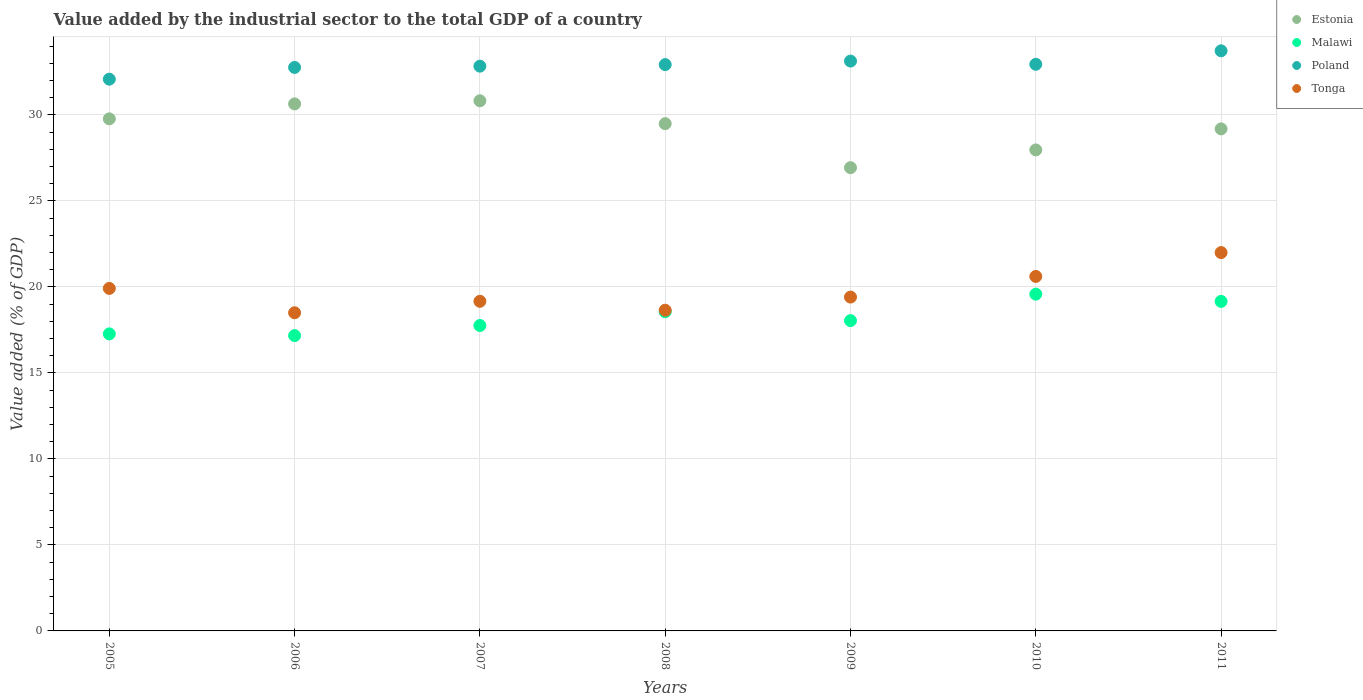How many different coloured dotlines are there?
Your answer should be very brief. 4. What is the value added by the industrial sector to the total GDP in Malawi in 2010?
Offer a terse response. 19.58. Across all years, what is the maximum value added by the industrial sector to the total GDP in Malawi?
Give a very brief answer. 19.58. Across all years, what is the minimum value added by the industrial sector to the total GDP in Estonia?
Make the answer very short. 26.94. In which year was the value added by the industrial sector to the total GDP in Poland minimum?
Provide a succinct answer. 2005. What is the total value added by the industrial sector to the total GDP in Malawi in the graph?
Keep it short and to the point. 127.55. What is the difference between the value added by the industrial sector to the total GDP in Tonga in 2005 and that in 2007?
Ensure brevity in your answer.  0.75. What is the difference between the value added by the industrial sector to the total GDP in Estonia in 2005 and the value added by the industrial sector to the total GDP in Tonga in 2007?
Keep it short and to the point. 10.61. What is the average value added by the industrial sector to the total GDP in Tonga per year?
Make the answer very short. 19.75. In the year 2008, what is the difference between the value added by the industrial sector to the total GDP in Malawi and value added by the industrial sector to the total GDP in Estonia?
Keep it short and to the point. -10.93. What is the ratio of the value added by the industrial sector to the total GDP in Estonia in 2005 to that in 2011?
Keep it short and to the point. 1.02. Is the value added by the industrial sector to the total GDP in Malawi in 2008 less than that in 2009?
Provide a short and direct response. No. Is the difference between the value added by the industrial sector to the total GDP in Malawi in 2005 and 2011 greater than the difference between the value added by the industrial sector to the total GDP in Estonia in 2005 and 2011?
Keep it short and to the point. No. What is the difference between the highest and the second highest value added by the industrial sector to the total GDP in Malawi?
Keep it short and to the point. 0.42. What is the difference between the highest and the lowest value added by the industrial sector to the total GDP in Estonia?
Provide a short and direct response. 3.89. In how many years, is the value added by the industrial sector to the total GDP in Estonia greater than the average value added by the industrial sector to the total GDP in Estonia taken over all years?
Your answer should be very brief. 4. Is the sum of the value added by the industrial sector to the total GDP in Poland in 2005 and 2011 greater than the maximum value added by the industrial sector to the total GDP in Estonia across all years?
Offer a terse response. Yes. How many dotlines are there?
Provide a short and direct response. 4. How many years are there in the graph?
Ensure brevity in your answer.  7. Are the values on the major ticks of Y-axis written in scientific E-notation?
Ensure brevity in your answer.  No. How many legend labels are there?
Give a very brief answer. 4. What is the title of the graph?
Ensure brevity in your answer.  Value added by the industrial sector to the total GDP of a country. What is the label or title of the Y-axis?
Provide a succinct answer. Value added (% of GDP). What is the Value added (% of GDP) of Estonia in 2005?
Offer a very short reply. 29.78. What is the Value added (% of GDP) of Malawi in 2005?
Give a very brief answer. 17.27. What is the Value added (% of GDP) in Poland in 2005?
Give a very brief answer. 32.08. What is the Value added (% of GDP) of Tonga in 2005?
Provide a succinct answer. 19.92. What is the Value added (% of GDP) of Estonia in 2006?
Provide a short and direct response. 30.64. What is the Value added (% of GDP) in Malawi in 2006?
Offer a very short reply. 17.17. What is the Value added (% of GDP) of Poland in 2006?
Your response must be concise. 32.76. What is the Value added (% of GDP) in Tonga in 2006?
Keep it short and to the point. 18.5. What is the Value added (% of GDP) of Estonia in 2007?
Your answer should be compact. 30.83. What is the Value added (% of GDP) in Malawi in 2007?
Your answer should be very brief. 17.76. What is the Value added (% of GDP) in Poland in 2007?
Your answer should be very brief. 32.84. What is the Value added (% of GDP) in Tonga in 2007?
Ensure brevity in your answer.  19.17. What is the Value added (% of GDP) in Estonia in 2008?
Give a very brief answer. 29.5. What is the Value added (% of GDP) in Malawi in 2008?
Keep it short and to the point. 18.56. What is the Value added (% of GDP) in Poland in 2008?
Offer a very short reply. 32.93. What is the Value added (% of GDP) in Tonga in 2008?
Offer a very short reply. 18.65. What is the Value added (% of GDP) of Estonia in 2009?
Provide a succinct answer. 26.94. What is the Value added (% of GDP) of Malawi in 2009?
Offer a terse response. 18.04. What is the Value added (% of GDP) in Poland in 2009?
Your answer should be very brief. 33.13. What is the Value added (% of GDP) in Tonga in 2009?
Provide a short and direct response. 19.41. What is the Value added (% of GDP) of Estonia in 2010?
Make the answer very short. 27.97. What is the Value added (% of GDP) in Malawi in 2010?
Ensure brevity in your answer.  19.58. What is the Value added (% of GDP) of Poland in 2010?
Your answer should be compact. 32.95. What is the Value added (% of GDP) in Tonga in 2010?
Your response must be concise. 20.61. What is the Value added (% of GDP) in Estonia in 2011?
Ensure brevity in your answer.  29.19. What is the Value added (% of GDP) in Malawi in 2011?
Your response must be concise. 19.16. What is the Value added (% of GDP) of Poland in 2011?
Provide a short and direct response. 33.73. What is the Value added (% of GDP) of Tonga in 2011?
Your answer should be compact. 22. Across all years, what is the maximum Value added (% of GDP) in Estonia?
Offer a terse response. 30.83. Across all years, what is the maximum Value added (% of GDP) of Malawi?
Your answer should be very brief. 19.58. Across all years, what is the maximum Value added (% of GDP) in Poland?
Keep it short and to the point. 33.73. Across all years, what is the maximum Value added (% of GDP) in Tonga?
Make the answer very short. 22. Across all years, what is the minimum Value added (% of GDP) of Estonia?
Offer a very short reply. 26.94. Across all years, what is the minimum Value added (% of GDP) in Malawi?
Ensure brevity in your answer.  17.17. Across all years, what is the minimum Value added (% of GDP) in Poland?
Your answer should be compact. 32.08. Across all years, what is the minimum Value added (% of GDP) in Tonga?
Offer a very short reply. 18.5. What is the total Value added (% of GDP) of Estonia in the graph?
Give a very brief answer. 204.84. What is the total Value added (% of GDP) in Malawi in the graph?
Keep it short and to the point. 127.55. What is the total Value added (% of GDP) in Poland in the graph?
Offer a terse response. 230.43. What is the total Value added (% of GDP) in Tonga in the graph?
Offer a very short reply. 138.25. What is the difference between the Value added (% of GDP) in Estonia in 2005 and that in 2006?
Make the answer very short. -0.87. What is the difference between the Value added (% of GDP) in Malawi in 2005 and that in 2006?
Your response must be concise. 0.1. What is the difference between the Value added (% of GDP) of Poland in 2005 and that in 2006?
Give a very brief answer. -0.68. What is the difference between the Value added (% of GDP) in Tonga in 2005 and that in 2006?
Offer a terse response. 1.42. What is the difference between the Value added (% of GDP) of Estonia in 2005 and that in 2007?
Your response must be concise. -1.05. What is the difference between the Value added (% of GDP) of Malawi in 2005 and that in 2007?
Provide a short and direct response. -0.49. What is the difference between the Value added (% of GDP) in Poland in 2005 and that in 2007?
Your answer should be very brief. -0.76. What is the difference between the Value added (% of GDP) of Tonga in 2005 and that in 2007?
Offer a terse response. 0.75. What is the difference between the Value added (% of GDP) in Estonia in 2005 and that in 2008?
Provide a succinct answer. 0.28. What is the difference between the Value added (% of GDP) in Malawi in 2005 and that in 2008?
Provide a short and direct response. -1.29. What is the difference between the Value added (% of GDP) of Poland in 2005 and that in 2008?
Your answer should be very brief. -0.85. What is the difference between the Value added (% of GDP) in Tonga in 2005 and that in 2008?
Offer a very short reply. 1.27. What is the difference between the Value added (% of GDP) of Estonia in 2005 and that in 2009?
Your response must be concise. 2.84. What is the difference between the Value added (% of GDP) in Malawi in 2005 and that in 2009?
Your answer should be very brief. -0.77. What is the difference between the Value added (% of GDP) in Poland in 2005 and that in 2009?
Provide a short and direct response. -1.05. What is the difference between the Value added (% of GDP) in Tonga in 2005 and that in 2009?
Your answer should be very brief. 0.5. What is the difference between the Value added (% of GDP) of Estonia in 2005 and that in 2010?
Make the answer very short. 1.81. What is the difference between the Value added (% of GDP) in Malawi in 2005 and that in 2010?
Provide a succinct answer. -2.31. What is the difference between the Value added (% of GDP) of Poland in 2005 and that in 2010?
Ensure brevity in your answer.  -0.87. What is the difference between the Value added (% of GDP) of Tonga in 2005 and that in 2010?
Ensure brevity in your answer.  -0.7. What is the difference between the Value added (% of GDP) in Estonia in 2005 and that in 2011?
Offer a very short reply. 0.58. What is the difference between the Value added (% of GDP) in Malawi in 2005 and that in 2011?
Provide a succinct answer. -1.89. What is the difference between the Value added (% of GDP) of Poland in 2005 and that in 2011?
Provide a succinct answer. -1.65. What is the difference between the Value added (% of GDP) of Tonga in 2005 and that in 2011?
Offer a terse response. -2.08. What is the difference between the Value added (% of GDP) in Estonia in 2006 and that in 2007?
Ensure brevity in your answer.  -0.18. What is the difference between the Value added (% of GDP) of Malawi in 2006 and that in 2007?
Your response must be concise. -0.59. What is the difference between the Value added (% of GDP) in Poland in 2006 and that in 2007?
Your answer should be very brief. -0.07. What is the difference between the Value added (% of GDP) in Tonga in 2006 and that in 2007?
Keep it short and to the point. -0.67. What is the difference between the Value added (% of GDP) of Estonia in 2006 and that in 2008?
Ensure brevity in your answer.  1.15. What is the difference between the Value added (% of GDP) of Malawi in 2006 and that in 2008?
Ensure brevity in your answer.  -1.39. What is the difference between the Value added (% of GDP) in Poland in 2006 and that in 2008?
Offer a terse response. -0.16. What is the difference between the Value added (% of GDP) of Tonga in 2006 and that in 2008?
Keep it short and to the point. -0.15. What is the difference between the Value added (% of GDP) in Estonia in 2006 and that in 2009?
Provide a short and direct response. 3.71. What is the difference between the Value added (% of GDP) in Malawi in 2006 and that in 2009?
Keep it short and to the point. -0.87. What is the difference between the Value added (% of GDP) of Poland in 2006 and that in 2009?
Make the answer very short. -0.37. What is the difference between the Value added (% of GDP) in Tonga in 2006 and that in 2009?
Your answer should be very brief. -0.91. What is the difference between the Value added (% of GDP) in Estonia in 2006 and that in 2010?
Provide a succinct answer. 2.68. What is the difference between the Value added (% of GDP) of Malawi in 2006 and that in 2010?
Give a very brief answer. -2.41. What is the difference between the Value added (% of GDP) of Poland in 2006 and that in 2010?
Your answer should be compact. -0.18. What is the difference between the Value added (% of GDP) of Tonga in 2006 and that in 2010?
Give a very brief answer. -2.11. What is the difference between the Value added (% of GDP) of Estonia in 2006 and that in 2011?
Ensure brevity in your answer.  1.45. What is the difference between the Value added (% of GDP) in Malawi in 2006 and that in 2011?
Keep it short and to the point. -1.99. What is the difference between the Value added (% of GDP) of Poland in 2006 and that in 2011?
Make the answer very short. -0.97. What is the difference between the Value added (% of GDP) in Tonga in 2006 and that in 2011?
Ensure brevity in your answer.  -3.5. What is the difference between the Value added (% of GDP) of Estonia in 2007 and that in 2008?
Give a very brief answer. 1.33. What is the difference between the Value added (% of GDP) in Malawi in 2007 and that in 2008?
Your response must be concise. -0.8. What is the difference between the Value added (% of GDP) of Poland in 2007 and that in 2008?
Ensure brevity in your answer.  -0.09. What is the difference between the Value added (% of GDP) of Tonga in 2007 and that in 2008?
Give a very brief answer. 0.52. What is the difference between the Value added (% of GDP) of Estonia in 2007 and that in 2009?
Ensure brevity in your answer.  3.89. What is the difference between the Value added (% of GDP) in Malawi in 2007 and that in 2009?
Offer a very short reply. -0.28. What is the difference between the Value added (% of GDP) in Poland in 2007 and that in 2009?
Give a very brief answer. -0.3. What is the difference between the Value added (% of GDP) of Tonga in 2007 and that in 2009?
Keep it short and to the point. -0.25. What is the difference between the Value added (% of GDP) in Estonia in 2007 and that in 2010?
Keep it short and to the point. 2.86. What is the difference between the Value added (% of GDP) in Malawi in 2007 and that in 2010?
Keep it short and to the point. -1.82. What is the difference between the Value added (% of GDP) of Poland in 2007 and that in 2010?
Provide a succinct answer. -0.11. What is the difference between the Value added (% of GDP) in Tonga in 2007 and that in 2010?
Make the answer very short. -1.45. What is the difference between the Value added (% of GDP) in Estonia in 2007 and that in 2011?
Provide a succinct answer. 1.63. What is the difference between the Value added (% of GDP) of Malawi in 2007 and that in 2011?
Offer a terse response. -1.4. What is the difference between the Value added (% of GDP) of Poland in 2007 and that in 2011?
Your response must be concise. -0.89. What is the difference between the Value added (% of GDP) in Tonga in 2007 and that in 2011?
Your answer should be compact. -2.83. What is the difference between the Value added (% of GDP) in Estonia in 2008 and that in 2009?
Provide a succinct answer. 2.56. What is the difference between the Value added (% of GDP) in Malawi in 2008 and that in 2009?
Make the answer very short. 0.52. What is the difference between the Value added (% of GDP) in Poland in 2008 and that in 2009?
Offer a terse response. -0.21. What is the difference between the Value added (% of GDP) of Tonga in 2008 and that in 2009?
Keep it short and to the point. -0.76. What is the difference between the Value added (% of GDP) in Estonia in 2008 and that in 2010?
Provide a succinct answer. 1.53. What is the difference between the Value added (% of GDP) of Malawi in 2008 and that in 2010?
Ensure brevity in your answer.  -1.02. What is the difference between the Value added (% of GDP) of Poland in 2008 and that in 2010?
Your response must be concise. -0.02. What is the difference between the Value added (% of GDP) of Tonga in 2008 and that in 2010?
Offer a very short reply. -1.96. What is the difference between the Value added (% of GDP) in Estonia in 2008 and that in 2011?
Provide a short and direct response. 0.3. What is the difference between the Value added (% of GDP) of Malawi in 2008 and that in 2011?
Make the answer very short. -0.6. What is the difference between the Value added (% of GDP) in Poland in 2008 and that in 2011?
Make the answer very short. -0.8. What is the difference between the Value added (% of GDP) of Tonga in 2008 and that in 2011?
Keep it short and to the point. -3.35. What is the difference between the Value added (% of GDP) of Estonia in 2009 and that in 2010?
Give a very brief answer. -1.03. What is the difference between the Value added (% of GDP) in Malawi in 2009 and that in 2010?
Provide a succinct answer. -1.54. What is the difference between the Value added (% of GDP) of Poland in 2009 and that in 2010?
Provide a succinct answer. 0.19. What is the difference between the Value added (% of GDP) in Tonga in 2009 and that in 2010?
Offer a terse response. -1.2. What is the difference between the Value added (% of GDP) of Estonia in 2009 and that in 2011?
Offer a very short reply. -2.26. What is the difference between the Value added (% of GDP) of Malawi in 2009 and that in 2011?
Give a very brief answer. -1.12. What is the difference between the Value added (% of GDP) of Poland in 2009 and that in 2011?
Provide a succinct answer. -0.6. What is the difference between the Value added (% of GDP) in Tonga in 2009 and that in 2011?
Offer a very short reply. -2.59. What is the difference between the Value added (% of GDP) in Estonia in 2010 and that in 2011?
Provide a succinct answer. -1.22. What is the difference between the Value added (% of GDP) of Malawi in 2010 and that in 2011?
Your answer should be compact. 0.42. What is the difference between the Value added (% of GDP) of Poland in 2010 and that in 2011?
Provide a short and direct response. -0.78. What is the difference between the Value added (% of GDP) of Tonga in 2010 and that in 2011?
Your response must be concise. -1.39. What is the difference between the Value added (% of GDP) in Estonia in 2005 and the Value added (% of GDP) in Malawi in 2006?
Your response must be concise. 12.6. What is the difference between the Value added (% of GDP) of Estonia in 2005 and the Value added (% of GDP) of Poland in 2006?
Ensure brevity in your answer.  -2.99. What is the difference between the Value added (% of GDP) of Estonia in 2005 and the Value added (% of GDP) of Tonga in 2006?
Provide a succinct answer. 11.28. What is the difference between the Value added (% of GDP) in Malawi in 2005 and the Value added (% of GDP) in Poland in 2006?
Your response must be concise. -15.49. What is the difference between the Value added (% of GDP) of Malawi in 2005 and the Value added (% of GDP) of Tonga in 2006?
Make the answer very short. -1.23. What is the difference between the Value added (% of GDP) of Poland in 2005 and the Value added (% of GDP) of Tonga in 2006?
Ensure brevity in your answer.  13.58. What is the difference between the Value added (% of GDP) in Estonia in 2005 and the Value added (% of GDP) in Malawi in 2007?
Offer a very short reply. 12.02. What is the difference between the Value added (% of GDP) in Estonia in 2005 and the Value added (% of GDP) in Poland in 2007?
Keep it short and to the point. -3.06. What is the difference between the Value added (% of GDP) in Estonia in 2005 and the Value added (% of GDP) in Tonga in 2007?
Provide a short and direct response. 10.61. What is the difference between the Value added (% of GDP) in Malawi in 2005 and the Value added (% of GDP) in Poland in 2007?
Give a very brief answer. -15.57. What is the difference between the Value added (% of GDP) in Malawi in 2005 and the Value added (% of GDP) in Tonga in 2007?
Your answer should be compact. -1.89. What is the difference between the Value added (% of GDP) in Poland in 2005 and the Value added (% of GDP) in Tonga in 2007?
Your response must be concise. 12.92. What is the difference between the Value added (% of GDP) of Estonia in 2005 and the Value added (% of GDP) of Malawi in 2008?
Your response must be concise. 11.21. What is the difference between the Value added (% of GDP) in Estonia in 2005 and the Value added (% of GDP) in Poland in 2008?
Offer a very short reply. -3.15. What is the difference between the Value added (% of GDP) in Estonia in 2005 and the Value added (% of GDP) in Tonga in 2008?
Keep it short and to the point. 11.13. What is the difference between the Value added (% of GDP) of Malawi in 2005 and the Value added (% of GDP) of Poland in 2008?
Make the answer very short. -15.66. What is the difference between the Value added (% of GDP) of Malawi in 2005 and the Value added (% of GDP) of Tonga in 2008?
Provide a succinct answer. -1.38. What is the difference between the Value added (% of GDP) of Poland in 2005 and the Value added (% of GDP) of Tonga in 2008?
Give a very brief answer. 13.43. What is the difference between the Value added (% of GDP) in Estonia in 2005 and the Value added (% of GDP) in Malawi in 2009?
Give a very brief answer. 11.73. What is the difference between the Value added (% of GDP) of Estonia in 2005 and the Value added (% of GDP) of Poland in 2009?
Provide a short and direct response. -3.36. What is the difference between the Value added (% of GDP) of Estonia in 2005 and the Value added (% of GDP) of Tonga in 2009?
Offer a very short reply. 10.36. What is the difference between the Value added (% of GDP) of Malawi in 2005 and the Value added (% of GDP) of Poland in 2009?
Make the answer very short. -15.86. What is the difference between the Value added (% of GDP) of Malawi in 2005 and the Value added (% of GDP) of Tonga in 2009?
Your response must be concise. -2.14. What is the difference between the Value added (% of GDP) in Poland in 2005 and the Value added (% of GDP) in Tonga in 2009?
Make the answer very short. 12.67. What is the difference between the Value added (% of GDP) in Estonia in 2005 and the Value added (% of GDP) in Malawi in 2010?
Give a very brief answer. 10.19. What is the difference between the Value added (% of GDP) of Estonia in 2005 and the Value added (% of GDP) of Poland in 2010?
Your answer should be very brief. -3.17. What is the difference between the Value added (% of GDP) in Estonia in 2005 and the Value added (% of GDP) in Tonga in 2010?
Offer a terse response. 9.16. What is the difference between the Value added (% of GDP) of Malawi in 2005 and the Value added (% of GDP) of Poland in 2010?
Offer a terse response. -15.68. What is the difference between the Value added (% of GDP) of Malawi in 2005 and the Value added (% of GDP) of Tonga in 2010?
Offer a very short reply. -3.34. What is the difference between the Value added (% of GDP) in Poland in 2005 and the Value added (% of GDP) in Tonga in 2010?
Your response must be concise. 11.47. What is the difference between the Value added (% of GDP) of Estonia in 2005 and the Value added (% of GDP) of Malawi in 2011?
Your response must be concise. 10.61. What is the difference between the Value added (% of GDP) of Estonia in 2005 and the Value added (% of GDP) of Poland in 2011?
Your answer should be very brief. -3.96. What is the difference between the Value added (% of GDP) in Estonia in 2005 and the Value added (% of GDP) in Tonga in 2011?
Your answer should be compact. 7.78. What is the difference between the Value added (% of GDP) of Malawi in 2005 and the Value added (% of GDP) of Poland in 2011?
Offer a very short reply. -16.46. What is the difference between the Value added (% of GDP) in Malawi in 2005 and the Value added (% of GDP) in Tonga in 2011?
Make the answer very short. -4.73. What is the difference between the Value added (% of GDP) in Poland in 2005 and the Value added (% of GDP) in Tonga in 2011?
Provide a succinct answer. 10.08. What is the difference between the Value added (% of GDP) of Estonia in 2006 and the Value added (% of GDP) of Malawi in 2007?
Provide a short and direct response. 12.89. What is the difference between the Value added (% of GDP) in Estonia in 2006 and the Value added (% of GDP) in Poland in 2007?
Your response must be concise. -2.19. What is the difference between the Value added (% of GDP) in Estonia in 2006 and the Value added (% of GDP) in Tonga in 2007?
Offer a terse response. 11.48. What is the difference between the Value added (% of GDP) of Malawi in 2006 and the Value added (% of GDP) of Poland in 2007?
Ensure brevity in your answer.  -15.67. What is the difference between the Value added (% of GDP) of Malawi in 2006 and the Value added (% of GDP) of Tonga in 2007?
Your response must be concise. -1.99. What is the difference between the Value added (% of GDP) of Poland in 2006 and the Value added (% of GDP) of Tonga in 2007?
Your answer should be compact. 13.6. What is the difference between the Value added (% of GDP) in Estonia in 2006 and the Value added (% of GDP) in Malawi in 2008?
Keep it short and to the point. 12.08. What is the difference between the Value added (% of GDP) of Estonia in 2006 and the Value added (% of GDP) of Poland in 2008?
Your answer should be very brief. -2.28. What is the difference between the Value added (% of GDP) of Estonia in 2006 and the Value added (% of GDP) of Tonga in 2008?
Provide a short and direct response. 12. What is the difference between the Value added (% of GDP) in Malawi in 2006 and the Value added (% of GDP) in Poland in 2008?
Your response must be concise. -15.76. What is the difference between the Value added (% of GDP) in Malawi in 2006 and the Value added (% of GDP) in Tonga in 2008?
Ensure brevity in your answer.  -1.47. What is the difference between the Value added (% of GDP) of Poland in 2006 and the Value added (% of GDP) of Tonga in 2008?
Provide a short and direct response. 14.12. What is the difference between the Value added (% of GDP) in Estonia in 2006 and the Value added (% of GDP) in Malawi in 2009?
Ensure brevity in your answer.  12.6. What is the difference between the Value added (% of GDP) in Estonia in 2006 and the Value added (% of GDP) in Poland in 2009?
Provide a short and direct response. -2.49. What is the difference between the Value added (% of GDP) in Estonia in 2006 and the Value added (% of GDP) in Tonga in 2009?
Make the answer very short. 11.23. What is the difference between the Value added (% of GDP) of Malawi in 2006 and the Value added (% of GDP) of Poland in 2009?
Offer a very short reply. -15.96. What is the difference between the Value added (% of GDP) in Malawi in 2006 and the Value added (% of GDP) in Tonga in 2009?
Your answer should be compact. -2.24. What is the difference between the Value added (% of GDP) in Poland in 2006 and the Value added (% of GDP) in Tonga in 2009?
Offer a very short reply. 13.35. What is the difference between the Value added (% of GDP) of Estonia in 2006 and the Value added (% of GDP) of Malawi in 2010?
Keep it short and to the point. 11.06. What is the difference between the Value added (% of GDP) in Estonia in 2006 and the Value added (% of GDP) in Poland in 2010?
Provide a succinct answer. -2.3. What is the difference between the Value added (% of GDP) of Estonia in 2006 and the Value added (% of GDP) of Tonga in 2010?
Ensure brevity in your answer.  10.03. What is the difference between the Value added (% of GDP) in Malawi in 2006 and the Value added (% of GDP) in Poland in 2010?
Ensure brevity in your answer.  -15.77. What is the difference between the Value added (% of GDP) of Malawi in 2006 and the Value added (% of GDP) of Tonga in 2010?
Provide a short and direct response. -3.44. What is the difference between the Value added (% of GDP) of Poland in 2006 and the Value added (% of GDP) of Tonga in 2010?
Your answer should be compact. 12.15. What is the difference between the Value added (% of GDP) of Estonia in 2006 and the Value added (% of GDP) of Malawi in 2011?
Offer a terse response. 11.48. What is the difference between the Value added (% of GDP) of Estonia in 2006 and the Value added (% of GDP) of Poland in 2011?
Offer a terse response. -3.09. What is the difference between the Value added (% of GDP) in Estonia in 2006 and the Value added (% of GDP) in Tonga in 2011?
Offer a terse response. 8.65. What is the difference between the Value added (% of GDP) in Malawi in 2006 and the Value added (% of GDP) in Poland in 2011?
Your answer should be compact. -16.56. What is the difference between the Value added (% of GDP) in Malawi in 2006 and the Value added (% of GDP) in Tonga in 2011?
Your response must be concise. -4.83. What is the difference between the Value added (% of GDP) in Poland in 2006 and the Value added (% of GDP) in Tonga in 2011?
Your response must be concise. 10.77. What is the difference between the Value added (% of GDP) of Estonia in 2007 and the Value added (% of GDP) of Malawi in 2008?
Provide a succinct answer. 12.27. What is the difference between the Value added (% of GDP) in Estonia in 2007 and the Value added (% of GDP) in Poland in 2008?
Keep it short and to the point. -2.1. What is the difference between the Value added (% of GDP) of Estonia in 2007 and the Value added (% of GDP) of Tonga in 2008?
Your answer should be compact. 12.18. What is the difference between the Value added (% of GDP) of Malawi in 2007 and the Value added (% of GDP) of Poland in 2008?
Give a very brief answer. -15.17. What is the difference between the Value added (% of GDP) in Malawi in 2007 and the Value added (% of GDP) in Tonga in 2008?
Ensure brevity in your answer.  -0.89. What is the difference between the Value added (% of GDP) of Poland in 2007 and the Value added (% of GDP) of Tonga in 2008?
Your response must be concise. 14.19. What is the difference between the Value added (% of GDP) of Estonia in 2007 and the Value added (% of GDP) of Malawi in 2009?
Keep it short and to the point. 12.78. What is the difference between the Value added (% of GDP) in Estonia in 2007 and the Value added (% of GDP) in Poland in 2009?
Make the answer very short. -2.31. What is the difference between the Value added (% of GDP) in Estonia in 2007 and the Value added (% of GDP) in Tonga in 2009?
Your answer should be very brief. 11.41. What is the difference between the Value added (% of GDP) of Malawi in 2007 and the Value added (% of GDP) of Poland in 2009?
Keep it short and to the point. -15.38. What is the difference between the Value added (% of GDP) of Malawi in 2007 and the Value added (% of GDP) of Tonga in 2009?
Provide a short and direct response. -1.65. What is the difference between the Value added (% of GDP) in Poland in 2007 and the Value added (% of GDP) in Tonga in 2009?
Your response must be concise. 13.43. What is the difference between the Value added (% of GDP) in Estonia in 2007 and the Value added (% of GDP) in Malawi in 2010?
Give a very brief answer. 11.24. What is the difference between the Value added (% of GDP) of Estonia in 2007 and the Value added (% of GDP) of Poland in 2010?
Provide a short and direct response. -2.12. What is the difference between the Value added (% of GDP) of Estonia in 2007 and the Value added (% of GDP) of Tonga in 2010?
Keep it short and to the point. 10.21. What is the difference between the Value added (% of GDP) of Malawi in 2007 and the Value added (% of GDP) of Poland in 2010?
Your answer should be compact. -15.19. What is the difference between the Value added (% of GDP) of Malawi in 2007 and the Value added (% of GDP) of Tonga in 2010?
Keep it short and to the point. -2.85. What is the difference between the Value added (% of GDP) in Poland in 2007 and the Value added (% of GDP) in Tonga in 2010?
Make the answer very short. 12.23. What is the difference between the Value added (% of GDP) of Estonia in 2007 and the Value added (% of GDP) of Malawi in 2011?
Offer a terse response. 11.67. What is the difference between the Value added (% of GDP) of Estonia in 2007 and the Value added (% of GDP) of Poland in 2011?
Offer a terse response. -2.9. What is the difference between the Value added (% of GDP) in Estonia in 2007 and the Value added (% of GDP) in Tonga in 2011?
Offer a terse response. 8.83. What is the difference between the Value added (% of GDP) of Malawi in 2007 and the Value added (% of GDP) of Poland in 2011?
Offer a very short reply. -15.97. What is the difference between the Value added (% of GDP) of Malawi in 2007 and the Value added (% of GDP) of Tonga in 2011?
Ensure brevity in your answer.  -4.24. What is the difference between the Value added (% of GDP) in Poland in 2007 and the Value added (% of GDP) in Tonga in 2011?
Provide a succinct answer. 10.84. What is the difference between the Value added (% of GDP) of Estonia in 2008 and the Value added (% of GDP) of Malawi in 2009?
Your answer should be very brief. 11.45. What is the difference between the Value added (% of GDP) of Estonia in 2008 and the Value added (% of GDP) of Poland in 2009?
Offer a terse response. -3.64. What is the difference between the Value added (% of GDP) of Estonia in 2008 and the Value added (% of GDP) of Tonga in 2009?
Ensure brevity in your answer.  10.08. What is the difference between the Value added (% of GDP) of Malawi in 2008 and the Value added (% of GDP) of Poland in 2009?
Provide a succinct answer. -14.57. What is the difference between the Value added (% of GDP) of Malawi in 2008 and the Value added (% of GDP) of Tonga in 2009?
Give a very brief answer. -0.85. What is the difference between the Value added (% of GDP) in Poland in 2008 and the Value added (% of GDP) in Tonga in 2009?
Offer a terse response. 13.52. What is the difference between the Value added (% of GDP) in Estonia in 2008 and the Value added (% of GDP) in Malawi in 2010?
Make the answer very short. 9.91. What is the difference between the Value added (% of GDP) in Estonia in 2008 and the Value added (% of GDP) in Poland in 2010?
Provide a succinct answer. -3.45. What is the difference between the Value added (% of GDP) of Estonia in 2008 and the Value added (% of GDP) of Tonga in 2010?
Keep it short and to the point. 8.88. What is the difference between the Value added (% of GDP) in Malawi in 2008 and the Value added (% of GDP) in Poland in 2010?
Offer a very short reply. -14.39. What is the difference between the Value added (% of GDP) in Malawi in 2008 and the Value added (% of GDP) in Tonga in 2010?
Provide a succinct answer. -2.05. What is the difference between the Value added (% of GDP) in Poland in 2008 and the Value added (% of GDP) in Tonga in 2010?
Provide a succinct answer. 12.32. What is the difference between the Value added (% of GDP) of Estonia in 2008 and the Value added (% of GDP) of Malawi in 2011?
Ensure brevity in your answer.  10.33. What is the difference between the Value added (% of GDP) of Estonia in 2008 and the Value added (% of GDP) of Poland in 2011?
Provide a succinct answer. -4.24. What is the difference between the Value added (% of GDP) of Estonia in 2008 and the Value added (% of GDP) of Tonga in 2011?
Keep it short and to the point. 7.5. What is the difference between the Value added (% of GDP) of Malawi in 2008 and the Value added (% of GDP) of Poland in 2011?
Offer a terse response. -15.17. What is the difference between the Value added (% of GDP) of Malawi in 2008 and the Value added (% of GDP) of Tonga in 2011?
Offer a very short reply. -3.44. What is the difference between the Value added (% of GDP) in Poland in 2008 and the Value added (% of GDP) in Tonga in 2011?
Your response must be concise. 10.93. What is the difference between the Value added (% of GDP) in Estonia in 2009 and the Value added (% of GDP) in Malawi in 2010?
Offer a very short reply. 7.35. What is the difference between the Value added (% of GDP) in Estonia in 2009 and the Value added (% of GDP) in Poland in 2010?
Give a very brief answer. -6.01. What is the difference between the Value added (% of GDP) in Estonia in 2009 and the Value added (% of GDP) in Tonga in 2010?
Give a very brief answer. 6.32. What is the difference between the Value added (% of GDP) in Malawi in 2009 and the Value added (% of GDP) in Poland in 2010?
Provide a succinct answer. -14.91. What is the difference between the Value added (% of GDP) of Malawi in 2009 and the Value added (% of GDP) of Tonga in 2010?
Give a very brief answer. -2.57. What is the difference between the Value added (% of GDP) in Poland in 2009 and the Value added (% of GDP) in Tonga in 2010?
Your response must be concise. 12.52. What is the difference between the Value added (% of GDP) of Estonia in 2009 and the Value added (% of GDP) of Malawi in 2011?
Provide a succinct answer. 7.78. What is the difference between the Value added (% of GDP) of Estonia in 2009 and the Value added (% of GDP) of Poland in 2011?
Make the answer very short. -6.79. What is the difference between the Value added (% of GDP) in Estonia in 2009 and the Value added (% of GDP) in Tonga in 2011?
Keep it short and to the point. 4.94. What is the difference between the Value added (% of GDP) in Malawi in 2009 and the Value added (% of GDP) in Poland in 2011?
Your response must be concise. -15.69. What is the difference between the Value added (% of GDP) in Malawi in 2009 and the Value added (% of GDP) in Tonga in 2011?
Offer a very short reply. -3.96. What is the difference between the Value added (% of GDP) of Poland in 2009 and the Value added (% of GDP) of Tonga in 2011?
Ensure brevity in your answer.  11.14. What is the difference between the Value added (% of GDP) of Estonia in 2010 and the Value added (% of GDP) of Malawi in 2011?
Your answer should be very brief. 8.81. What is the difference between the Value added (% of GDP) of Estonia in 2010 and the Value added (% of GDP) of Poland in 2011?
Give a very brief answer. -5.76. What is the difference between the Value added (% of GDP) of Estonia in 2010 and the Value added (% of GDP) of Tonga in 2011?
Your answer should be very brief. 5.97. What is the difference between the Value added (% of GDP) in Malawi in 2010 and the Value added (% of GDP) in Poland in 2011?
Give a very brief answer. -14.15. What is the difference between the Value added (% of GDP) of Malawi in 2010 and the Value added (% of GDP) of Tonga in 2011?
Offer a terse response. -2.42. What is the difference between the Value added (% of GDP) in Poland in 2010 and the Value added (% of GDP) in Tonga in 2011?
Provide a succinct answer. 10.95. What is the average Value added (% of GDP) in Estonia per year?
Give a very brief answer. 29.26. What is the average Value added (% of GDP) of Malawi per year?
Provide a short and direct response. 18.22. What is the average Value added (% of GDP) in Poland per year?
Keep it short and to the point. 32.92. What is the average Value added (% of GDP) in Tonga per year?
Make the answer very short. 19.75. In the year 2005, what is the difference between the Value added (% of GDP) of Estonia and Value added (% of GDP) of Malawi?
Your answer should be very brief. 12.5. In the year 2005, what is the difference between the Value added (% of GDP) in Estonia and Value added (% of GDP) in Poland?
Your answer should be compact. -2.31. In the year 2005, what is the difference between the Value added (% of GDP) in Estonia and Value added (% of GDP) in Tonga?
Provide a short and direct response. 9.86. In the year 2005, what is the difference between the Value added (% of GDP) of Malawi and Value added (% of GDP) of Poland?
Give a very brief answer. -14.81. In the year 2005, what is the difference between the Value added (% of GDP) of Malawi and Value added (% of GDP) of Tonga?
Ensure brevity in your answer.  -2.64. In the year 2005, what is the difference between the Value added (% of GDP) in Poland and Value added (% of GDP) in Tonga?
Give a very brief answer. 12.17. In the year 2006, what is the difference between the Value added (% of GDP) in Estonia and Value added (% of GDP) in Malawi?
Give a very brief answer. 13.47. In the year 2006, what is the difference between the Value added (% of GDP) of Estonia and Value added (% of GDP) of Poland?
Your answer should be very brief. -2.12. In the year 2006, what is the difference between the Value added (% of GDP) of Estonia and Value added (% of GDP) of Tonga?
Your response must be concise. 12.14. In the year 2006, what is the difference between the Value added (% of GDP) of Malawi and Value added (% of GDP) of Poland?
Offer a very short reply. -15.59. In the year 2006, what is the difference between the Value added (% of GDP) in Malawi and Value added (% of GDP) in Tonga?
Offer a terse response. -1.33. In the year 2006, what is the difference between the Value added (% of GDP) of Poland and Value added (% of GDP) of Tonga?
Offer a terse response. 14.26. In the year 2007, what is the difference between the Value added (% of GDP) in Estonia and Value added (% of GDP) in Malawi?
Ensure brevity in your answer.  13.07. In the year 2007, what is the difference between the Value added (% of GDP) in Estonia and Value added (% of GDP) in Poland?
Provide a short and direct response. -2.01. In the year 2007, what is the difference between the Value added (% of GDP) in Estonia and Value added (% of GDP) in Tonga?
Your answer should be very brief. 11.66. In the year 2007, what is the difference between the Value added (% of GDP) of Malawi and Value added (% of GDP) of Poland?
Make the answer very short. -15.08. In the year 2007, what is the difference between the Value added (% of GDP) of Malawi and Value added (% of GDP) of Tonga?
Offer a terse response. -1.41. In the year 2007, what is the difference between the Value added (% of GDP) in Poland and Value added (% of GDP) in Tonga?
Make the answer very short. 13.67. In the year 2008, what is the difference between the Value added (% of GDP) of Estonia and Value added (% of GDP) of Malawi?
Keep it short and to the point. 10.93. In the year 2008, what is the difference between the Value added (% of GDP) of Estonia and Value added (% of GDP) of Poland?
Your answer should be compact. -3.43. In the year 2008, what is the difference between the Value added (% of GDP) in Estonia and Value added (% of GDP) in Tonga?
Ensure brevity in your answer.  10.85. In the year 2008, what is the difference between the Value added (% of GDP) in Malawi and Value added (% of GDP) in Poland?
Provide a short and direct response. -14.37. In the year 2008, what is the difference between the Value added (% of GDP) in Malawi and Value added (% of GDP) in Tonga?
Your answer should be very brief. -0.09. In the year 2008, what is the difference between the Value added (% of GDP) of Poland and Value added (% of GDP) of Tonga?
Give a very brief answer. 14.28. In the year 2009, what is the difference between the Value added (% of GDP) of Estonia and Value added (% of GDP) of Malawi?
Your answer should be very brief. 8.89. In the year 2009, what is the difference between the Value added (% of GDP) of Estonia and Value added (% of GDP) of Poland?
Give a very brief answer. -6.2. In the year 2009, what is the difference between the Value added (% of GDP) of Estonia and Value added (% of GDP) of Tonga?
Your response must be concise. 7.52. In the year 2009, what is the difference between the Value added (% of GDP) of Malawi and Value added (% of GDP) of Poland?
Keep it short and to the point. -15.09. In the year 2009, what is the difference between the Value added (% of GDP) of Malawi and Value added (% of GDP) of Tonga?
Offer a terse response. -1.37. In the year 2009, what is the difference between the Value added (% of GDP) of Poland and Value added (% of GDP) of Tonga?
Your answer should be compact. 13.72. In the year 2010, what is the difference between the Value added (% of GDP) of Estonia and Value added (% of GDP) of Malawi?
Give a very brief answer. 8.39. In the year 2010, what is the difference between the Value added (% of GDP) in Estonia and Value added (% of GDP) in Poland?
Make the answer very short. -4.98. In the year 2010, what is the difference between the Value added (% of GDP) in Estonia and Value added (% of GDP) in Tonga?
Your response must be concise. 7.36. In the year 2010, what is the difference between the Value added (% of GDP) in Malawi and Value added (% of GDP) in Poland?
Provide a short and direct response. -13.37. In the year 2010, what is the difference between the Value added (% of GDP) in Malawi and Value added (% of GDP) in Tonga?
Ensure brevity in your answer.  -1.03. In the year 2010, what is the difference between the Value added (% of GDP) in Poland and Value added (% of GDP) in Tonga?
Make the answer very short. 12.34. In the year 2011, what is the difference between the Value added (% of GDP) in Estonia and Value added (% of GDP) in Malawi?
Give a very brief answer. 10.03. In the year 2011, what is the difference between the Value added (% of GDP) in Estonia and Value added (% of GDP) in Poland?
Make the answer very short. -4.54. In the year 2011, what is the difference between the Value added (% of GDP) in Estonia and Value added (% of GDP) in Tonga?
Provide a short and direct response. 7.19. In the year 2011, what is the difference between the Value added (% of GDP) of Malawi and Value added (% of GDP) of Poland?
Provide a succinct answer. -14.57. In the year 2011, what is the difference between the Value added (% of GDP) of Malawi and Value added (% of GDP) of Tonga?
Provide a succinct answer. -2.84. In the year 2011, what is the difference between the Value added (% of GDP) in Poland and Value added (% of GDP) in Tonga?
Keep it short and to the point. 11.73. What is the ratio of the Value added (% of GDP) in Estonia in 2005 to that in 2006?
Your response must be concise. 0.97. What is the ratio of the Value added (% of GDP) in Malawi in 2005 to that in 2006?
Your response must be concise. 1.01. What is the ratio of the Value added (% of GDP) of Poland in 2005 to that in 2006?
Offer a very short reply. 0.98. What is the ratio of the Value added (% of GDP) of Tonga in 2005 to that in 2006?
Ensure brevity in your answer.  1.08. What is the ratio of the Value added (% of GDP) in Estonia in 2005 to that in 2007?
Ensure brevity in your answer.  0.97. What is the ratio of the Value added (% of GDP) in Malawi in 2005 to that in 2007?
Ensure brevity in your answer.  0.97. What is the ratio of the Value added (% of GDP) in Poland in 2005 to that in 2007?
Keep it short and to the point. 0.98. What is the ratio of the Value added (% of GDP) of Tonga in 2005 to that in 2007?
Your answer should be very brief. 1.04. What is the ratio of the Value added (% of GDP) of Estonia in 2005 to that in 2008?
Provide a succinct answer. 1.01. What is the ratio of the Value added (% of GDP) in Malawi in 2005 to that in 2008?
Offer a terse response. 0.93. What is the ratio of the Value added (% of GDP) of Poland in 2005 to that in 2008?
Give a very brief answer. 0.97. What is the ratio of the Value added (% of GDP) in Tonga in 2005 to that in 2008?
Keep it short and to the point. 1.07. What is the ratio of the Value added (% of GDP) in Estonia in 2005 to that in 2009?
Your answer should be compact. 1.11. What is the ratio of the Value added (% of GDP) of Malawi in 2005 to that in 2009?
Your answer should be very brief. 0.96. What is the ratio of the Value added (% of GDP) of Poland in 2005 to that in 2009?
Your answer should be very brief. 0.97. What is the ratio of the Value added (% of GDP) of Tonga in 2005 to that in 2009?
Provide a succinct answer. 1.03. What is the ratio of the Value added (% of GDP) in Estonia in 2005 to that in 2010?
Provide a short and direct response. 1.06. What is the ratio of the Value added (% of GDP) of Malawi in 2005 to that in 2010?
Offer a terse response. 0.88. What is the ratio of the Value added (% of GDP) of Poland in 2005 to that in 2010?
Provide a short and direct response. 0.97. What is the ratio of the Value added (% of GDP) of Tonga in 2005 to that in 2010?
Provide a succinct answer. 0.97. What is the ratio of the Value added (% of GDP) in Estonia in 2005 to that in 2011?
Your response must be concise. 1.02. What is the ratio of the Value added (% of GDP) of Malawi in 2005 to that in 2011?
Your answer should be compact. 0.9. What is the ratio of the Value added (% of GDP) in Poland in 2005 to that in 2011?
Your response must be concise. 0.95. What is the ratio of the Value added (% of GDP) of Tonga in 2005 to that in 2011?
Make the answer very short. 0.91. What is the ratio of the Value added (% of GDP) of Estonia in 2006 to that in 2007?
Keep it short and to the point. 0.99. What is the ratio of the Value added (% of GDP) of Poland in 2006 to that in 2007?
Provide a short and direct response. 1. What is the ratio of the Value added (% of GDP) of Tonga in 2006 to that in 2007?
Make the answer very short. 0.97. What is the ratio of the Value added (% of GDP) of Estonia in 2006 to that in 2008?
Your response must be concise. 1.04. What is the ratio of the Value added (% of GDP) of Malawi in 2006 to that in 2008?
Your answer should be compact. 0.93. What is the ratio of the Value added (% of GDP) of Tonga in 2006 to that in 2008?
Make the answer very short. 0.99. What is the ratio of the Value added (% of GDP) in Estonia in 2006 to that in 2009?
Give a very brief answer. 1.14. What is the ratio of the Value added (% of GDP) in Malawi in 2006 to that in 2009?
Provide a short and direct response. 0.95. What is the ratio of the Value added (% of GDP) in Poland in 2006 to that in 2009?
Offer a very short reply. 0.99. What is the ratio of the Value added (% of GDP) of Tonga in 2006 to that in 2009?
Give a very brief answer. 0.95. What is the ratio of the Value added (% of GDP) in Estonia in 2006 to that in 2010?
Make the answer very short. 1.1. What is the ratio of the Value added (% of GDP) of Malawi in 2006 to that in 2010?
Your response must be concise. 0.88. What is the ratio of the Value added (% of GDP) in Tonga in 2006 to that in 2010?
Provide a succinct answer. 0.9. What is the ratio of the Value added (% of GDP) of Estonia in 2006 to that in 2011?
Ensure brevity in your answer.  1.05. What is the ratio of the Value added (% of GDP) in Malawi in 2006 to that in 2011?
Offer a terse response. 0.9. What is the ratio of the Value added (% of GDP) in Poland in 2006 to that in 2011?
Provide a succinct answer. 0.97. What is the ratio of the Value added (% of GDP) of Tonga in 2006 to that in 2011?
Your answer should be very brief. 0.84. What is the ratio of the Value added (% of GDP) of Estonia in 2007 to that in 2008?
Give a very brief answer. 1.05. What is the ratio of the Value added (% of GDP) in Malawi in 2007 to that in 2008?
Offer a very short reply. 0.96. What is the ratio of the Value added (% of GDP) of Tonga in 2007 to that in 2008?
Ensure brevity in your answer.  1.03. What is the ratio of the Value added (% of GDP) in Estonia in 2007 to that in 2009?
Your answer should be compact. 1.14. What is the ratio of the Value added (% of GDP) in Malawi in 2007 to that in 2009?
Your answer should be compact. 0.98. What is the ratio of the Value added (% of GDP) in Tonga in 2007 to that in 2009?
Provide a short and direct response. 0.99. What is the ratio of the Value added (% of GDP) in Estonia in 2007 to that in 2010?
Your answer should be compact. 1.1. What is the ratio of the Value added (% of GDP) of Malawi in 2007 to that in 2010?
Provide a succinct answer. 0.91. What is the ratio of the Value added (% of GDP) in Tonga in 2007 to that in 2010?
Provide a succinct answer. 0.93. What is the ratio of the Value added (% of GDP) in Estonia in 2007 to that in 2011?
Offer a terse response. 1.06. What is the ratio of the Value added (% of GDP) of Malawi in 2007 to that in 2011?
Keep it short and to the point. 0.93. What is the ratio of the Value added (% of GDP) in Poland in 2007 to that in 2011?
Make the answer very short. 0.97. What is the ratio of the Value added (% of GDP) in Tonga in 2007 to that in 2011?
Your response must be concise. 0.87. What is the ratio of the Value added (% of GDP) in Estonia in 2008 to that in 2009?
Provide a short and direct response. 1.09. What is the ratio of the Value added (% of GDP) in Malawi in 2008 to that in 2009?
Your response must be concise. 1.03. What is the ratio of the Value added (% of GDP) in Tonga in 2008 to that in 2009?
Your response must be concise. 0.96. What is the ratio of the Value added (% of GDP) of Estonia in 2008 to that in 2010?
Provide a short and direct response. 1.05. What is the ratio of the Value added (% of GDP) of Malawi in 2008 to that in 2010?
Your response must be concise. 0.95. What is the ratio of the Value added (% of GDP) of Poland in 2008 to that in 2010?
Your response must be concise. 1. What is the ratio of the Value added (% of GDP) of Tonga in 2008 to that in 2010?
Your answer should be very brief. 0.9. What is the ratio of the Value added (% of GDP) in Estonia in 2008 to that in 2011?
Keep it short and to the point. 1.01. What is the ratio of the Value added (% of GDP) in Malawi in 2008 to that in 2011?
Provide a succinct answer. 0.97. What is the ratio of the Value added (% of GDP) in Poland in 2008 to that in 2011?
Make the answer very short. 0.98. What is the ratio of the Value added (% of GDP) in Tonga in 2008 to that in 2011?
Give a very brief answer. 0.85. What is the ratio of the Value added (% of GDP) of Estonia in 2009 to that in 2010?
Ensure brevity in your answer.  0.96. What is the ratio of the Value added (% of GDP) of Malawi in 2009 to that in 2010?
Provide a succinct answer. 0.92. What is the ratio of the Value added (% of GDP) of Poland in 2009 to that in 2010?
Provide a succinct answer. 1.01. What is the ratio of the Value added (% of GDP) in Tonga in 2009 to that in 2010?
Ensure brevity in your answer.  0.94. What is the ratio of the Value added (% of GDP) in Estonia in 2009 to that in 2011?
Provide a short and direct response. 0.92. What is the ratio of the Value added (% of GDP) of Malawi in 2009 to that in 2011?
Provide a short and direct response. 0.94. What is the ratio of the Value added (% of GDP) in Poland in 2009 to that in 2011?
Provide a short and direct response. 0.98. What is the ratio of the Value added (% of GDP) in Tonga in 2009 to that in 2011?
Provide a succinct answer. 0.88. What is the ratio of the Value added (% of GDP) of Estonia in 2010 to that in 2011?
Offer a terse response. 0.96. What is the ratio of the Value added (% of GDP) of Malawi in 2010 to that in 2011?
Ensure brevity in your answer.  1.02. What is the ratio of the Value added (% of GDP) in Poland in 2010 to that in 2011?
Offer a very short reply. 0.98. What is the ratio of the Value added (% of GDP) in Tonga in 2010 to that in 2011?
Offer a terse response. 0.94. What is the difference between the highest and the second highest Value added (% of GDP) in Estonia?
Provide a succinct answer. 0.18. What is the difference between the highest and the second highest Value added (% of GDP) of Malawi?
Your response must be concise. 0.42. What is the difference between the highest and the second highest Value added (% of GDP) of Poland?
Provide a succinct answer. 0.6. What is the difference between the highest and the second highest Value added (% of GDP) of Tonga?
Offer a very short reply. 1.39. What is the difference between the highest and the lowest Value added (% of GDP) of Estonia?
Offer a terse response. 3.89. What is the difference between the highest and the lowest Value added (% of GDP) in Malawi?
Keep it short and to the point. 2.41. What is the difference between the highest and the lowest Value added (% of GDP) of Poland?
Provide a succinct answer. 1.65. What is the difference between the highest and the lowest Value added (% of GDP) in Tonga?
Provide a short and direct response. 3.5. 